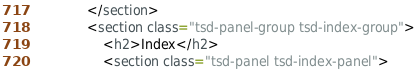Convert code to text. <code><loc_0><loc_0><loc_500><loc_500><_HTML_>			</section>
			<section class="tsd-panel-group tsd-index-group">
				<h2>Index</h2>
				<section class="tsd-panel tsd-index-panel"></code> 